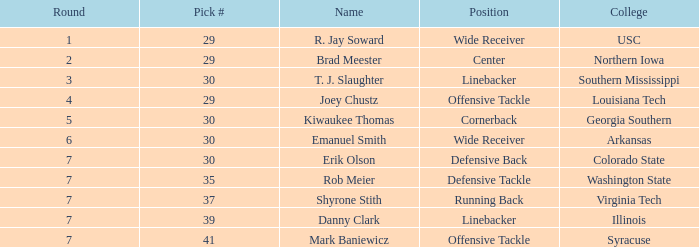What is the spot with a round 3 pick for r. jay soward? Wide Receiver. 